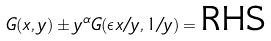<formula> <loc_0><loc_0><loc_500><loc_500>G ( x , y ) \pm y ^ { \alpha } G ( \epsilon x / y , 1 / y ) = \text {RHS}</formula> 